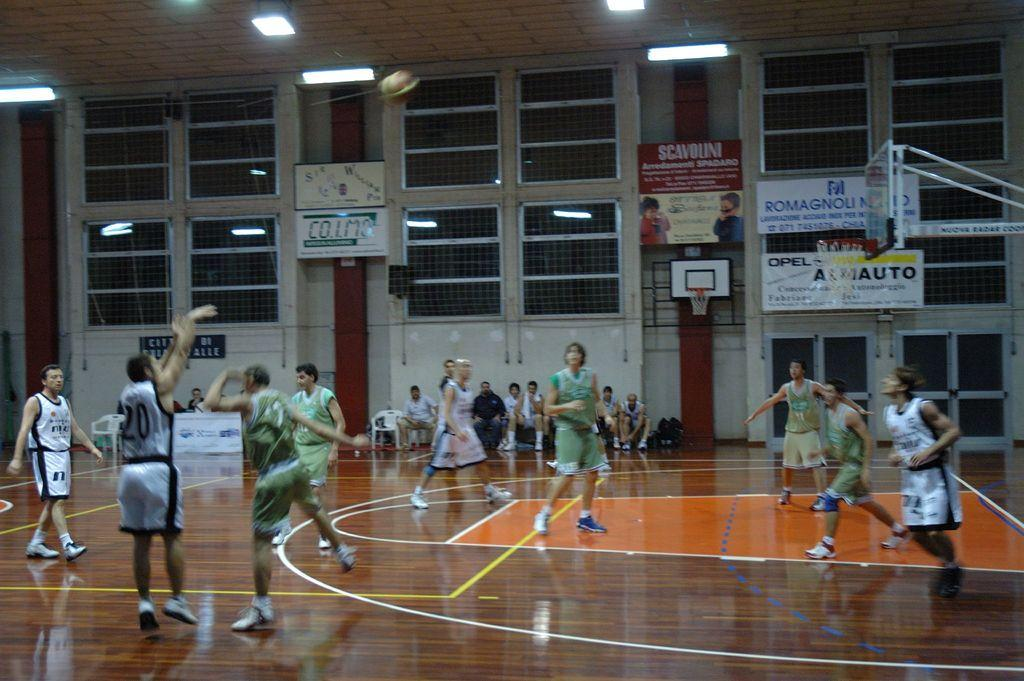<image>
Give a short and clear explanation of the subsequent image. A basketball game takes place in a court with ads in another language on the walls. 